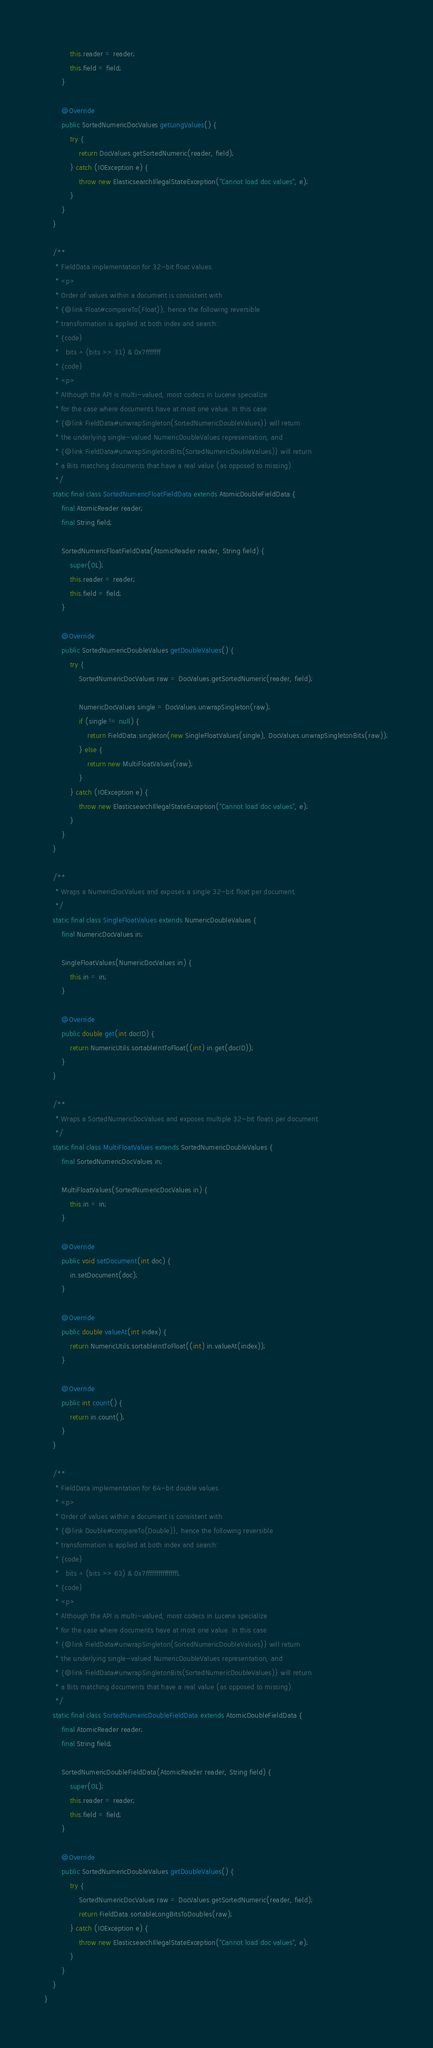Convert code to text. <code><loc_0><loc_0><loc_500><loc_500><_Java_>            this.reader = reader;
            this.field = field;
        }

        @Override
        public SortedNumericDocValues getLongValues() {
            try {
                return DocValues.getSortedNumeric(reader, field);
            } catch (IOException e) {
                throw new ElasticsearchIllegalStateException("Cannot load doc values", e);
            }
        }
    }

    /**
     * FieldData implementation for 32-bit float values.
     * <p>
     * Order of values within a document is consistent with
     * {@link Float#compareTo(Float)}, hence the following reversible
     * transformation is applied at both index and search:
     * {code}
     *   bits ^ (bits >> 31) & 0x7fffffff
     * {code}
     * <p>
     * Although the API is multi-valued, most codecs in Lucene specialize 
     * for the case where documents have at most one value. In this case
     * {@link FieldData#unwrapSingleton(SortedNumericDoubleValues)} will return
     * the underlying single-valued NumericDoubleValues representation, and 
     * {@link FieldData#unwrapSingletonBits(SortedNumericDoubleValues)} will return
     * a Bits matching documents that have a real value (as opposed to missing).
     */
    static final class SortedNumericFloatFieldData extends AtomicDoubleFieldData {
        final AtomicReader reader;
        final String field;

        SortedNumericFloatFieldData(AtomicReader reader, String field) {
            super(0L);
            this.reader = reader;
            this.field = field;
        }

        @Override
        public SortedNumericDoubleValues getDoubleValues() {
            try {
                SortedNumericDocValues raw = DocValues.getSortedNumeric(reader, field);

                NumericDocValues single = DocValues.unwrapSingleton(raw);
                if (single != null) {
                    return FieldData.singleton(new SingleFloatValues(single), DocValues.unwrapSingletonBits(raw));
                } else {
                    return new MultiFloatValues(raw);
                }
            } catch (IOException e) {
                throw new ElasticsearchIllegalStateException("Cannot load doc values", e);
            }
        }
    }

    /** 
     * Wraps a NumericDocValues and exposes a single 32-bit float per document.
     */
    static final class SingleFloatValues extends NumericDoubleValues {
        final NumericDocValues in;

        SingleFloatValues(NumericDocValues in) {
            this.in = in;
        }

        @Override
        public double get(int docID) {
            return NumericUtils.sortableIntToFloat((int) in.get(docID));
        }
    }

    /** 
     * Wraps a SortedNumericDocValues and exposes multiple 32-bit floats per document.
     */
    static final class MultiFloatValues extends SortedNumericDoubleValues {
        final SortedNumericDocValues in;

        MultiFloatValues(SortedNumericDocValues in) {
            this.in = in;
        }

        @Override
        public void setDocument(int doc) {
            in.setDocument(doc);
        }

        @Override
        public double valueAt(int index) {
            return NumericUtils.sortableIntToFloat((int) in.valueAt(index));
        }

        @Override
        public int count() {
            return in.count();
        }
    }

    /**
     * FieldData implementation for 64-bit double values.
     * <p>
     * Order of values within a document is consistent with
     * {@link Double#compareTo(Double)}, hence the following reversible
     * transformation is applied at both index and search:
     * {code}
     *   bits ^ (bits >> 63) & 0x7fffffffffffffffL
     * {code}
     * <p>
     * Although the API is multi-valued, most codecs in Lucene specialize 
     * for the case where documents have at most one value. In this case
     * {@link FieldData#unwrapSingleton(SortedNumericDoubleValues)} will return
     * the underlying single-valued NumericDoubleValues representation, and 
     * {@link FieldData#unwrapSingletonBits(SortedNumericDoubleValues)} will return
     * a Bits matching documents that have a real value (as opposed to missing).
     */
    static final class SortedNumericDoubleFieldData extends AtomicDoubleFieldData {
        final AtomicReader reader;
        final String field;

        SortedNumericDoubleFieldData(AtomicReader reader, String field) {
            super(0L);
            this.reader = reader;
            this.field = field;
        }

        @Override
        public SortedNumericDoubleValues getDoubleValues() {
            try {
                SortedNumericDocValues raw = DocValues.getSortedNumeric(reader, field);
                return FieldData.sortableLongBitsToDoubles(raw);
            } catch (IOException e) {
                throw new ElasticsearchIllegalStateException("Cannot load doc values", e);
            }
        }
    }
}
</code> 